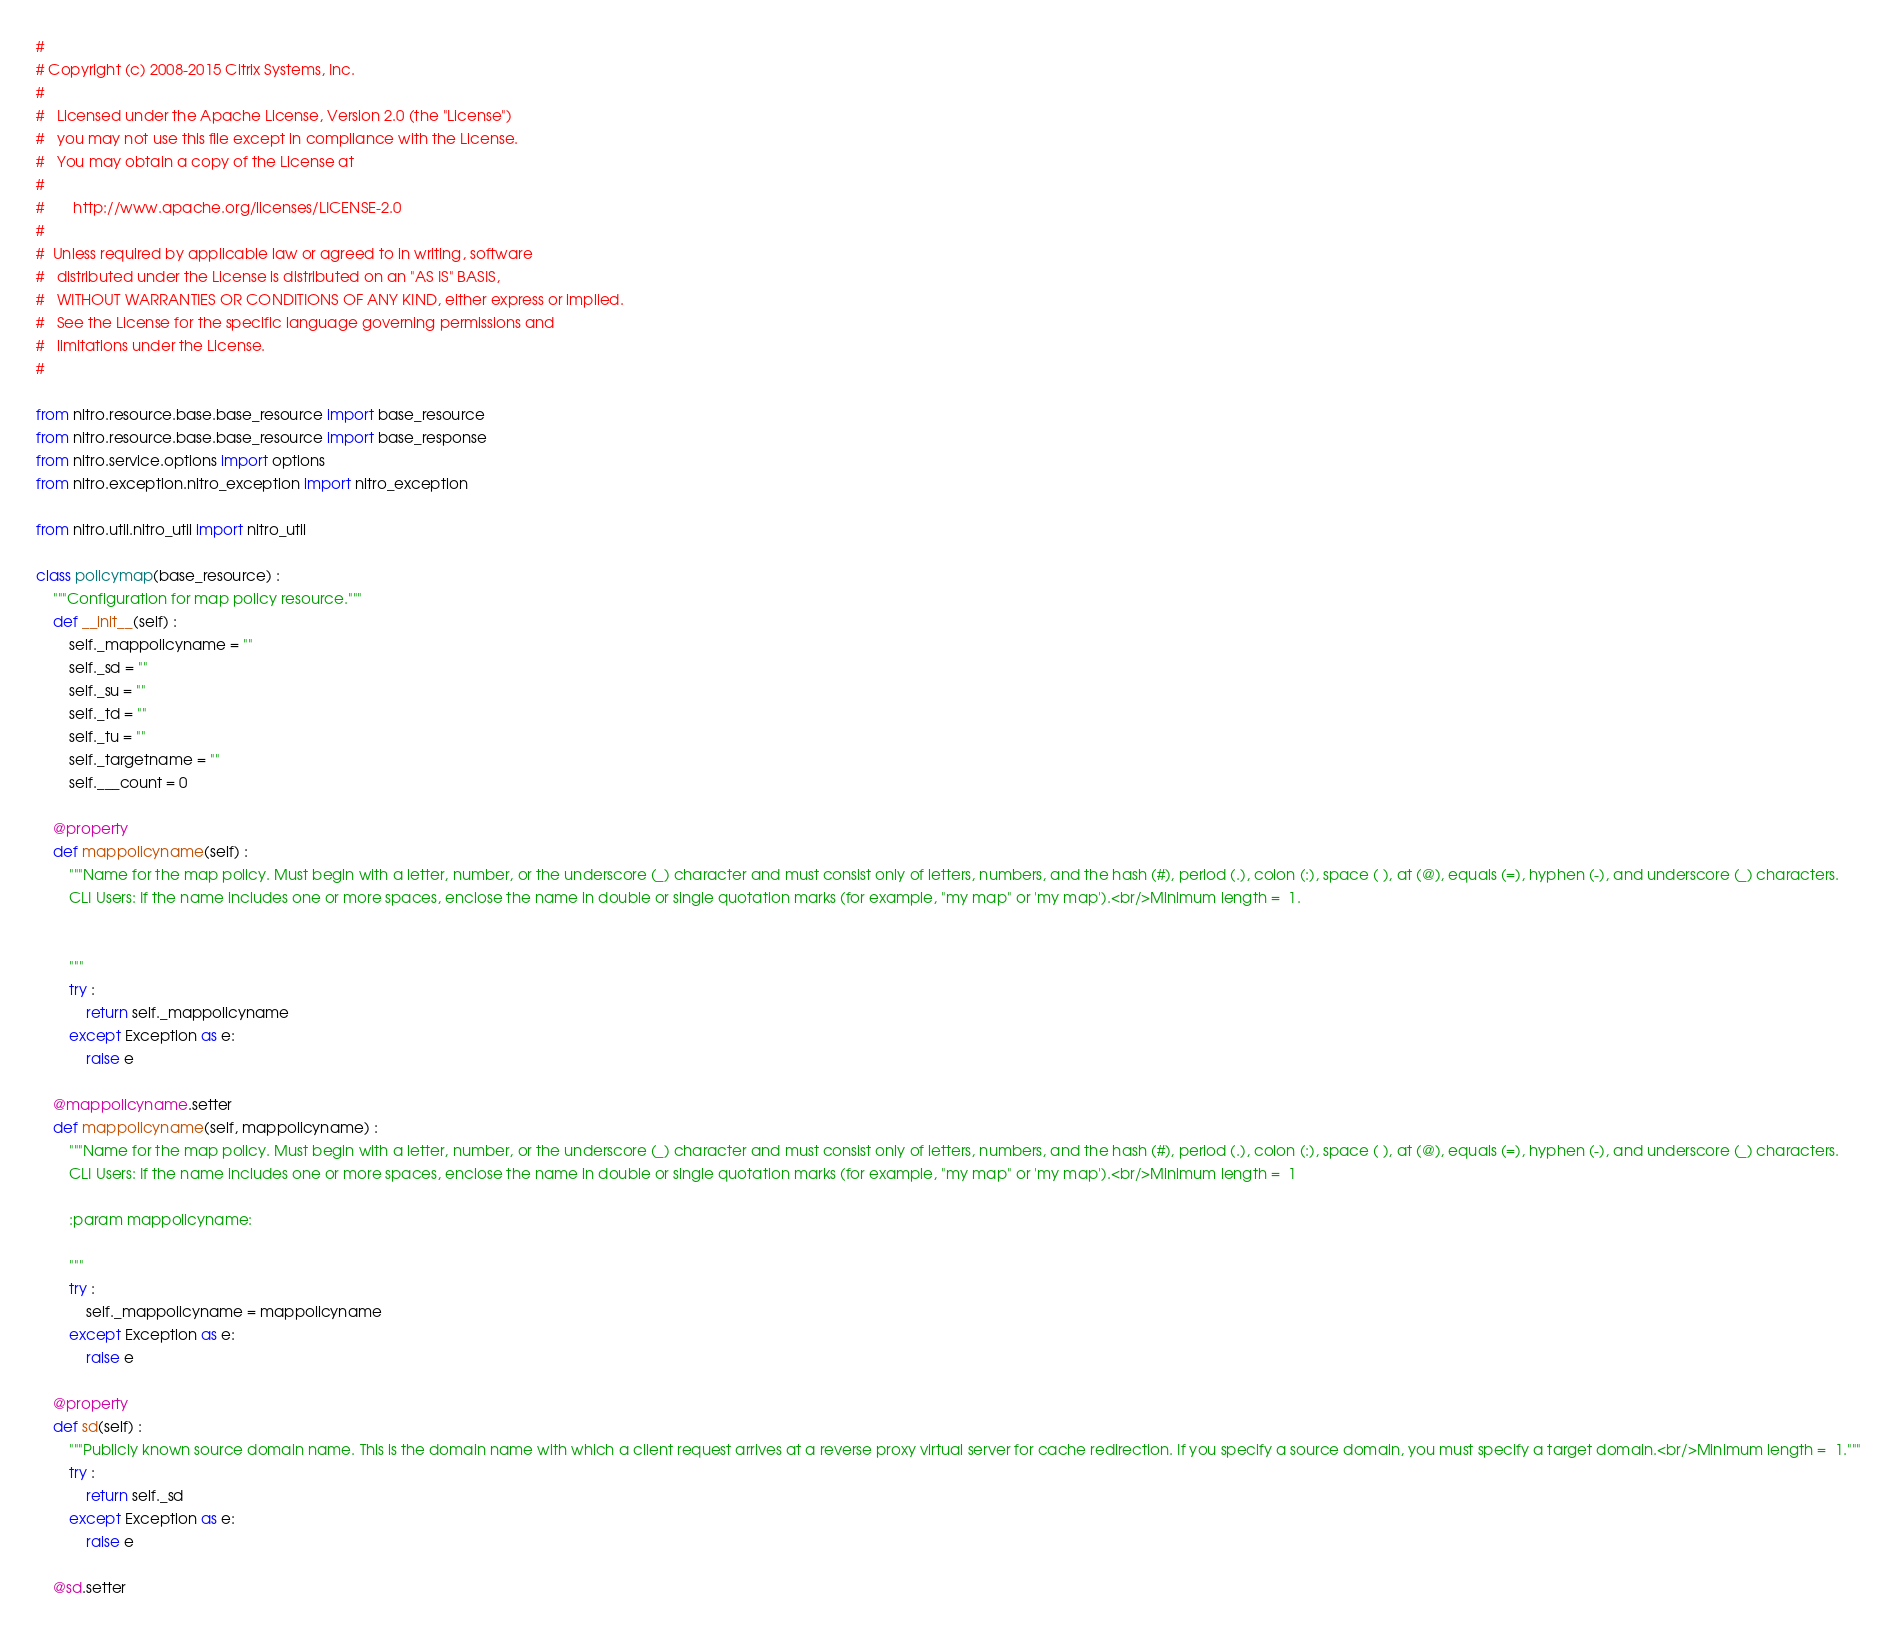Convert code to text. <code><loc_0><loc_0><loc_500><loc_500><_Python_>#
# Copyright (c) 2008-2015 Citrix Systems, Inc.
#
#   Licensed under the Apache License, Version 2.0 (the "License")
#   you may not use this file except in compliance with the License.
#   You may obtain a copy of the License at
#
#       http://www.apache.org/licenses/LICENSE-2.0
#
#  Unless required by applicable law or agreed to in writing, software
#   distributed under the License is distributed on an "AS IS" BASIS,
#   WITHOUT WARRANTIES OR CONDITIONS OF ANY KIND, either express or implied.
#   See the License for the specific language governing permissions and
#   limitations under the License.
#

from nitro.resource.base.base_resource import base_resource
from nitro.resource.base.base_resource import base_response
from nitro.service.options import options
from nitro.exception.nitro_exception import nitro_exception

from nitro.util.nitro_util import nitro_util

class policymap(base_resource) :
    """Configuration for map policy resource."""
    def __init__(self) :
        self._mappolicyname = ""
        self._sd = ""
        self._su = ""
        self._td = ""
        self._tu = ""
        self._targetname = ""
        self.___count = 0

    @property
    def mappolicyname(self) :
        """Name for the map policy. Must begin with a letter, number, or the underscore (_) character and must consist only of letters, numbers, and the hash (#), period (.), colon (:), space ( ), at (@), equals (=), hyphen (-), and underscore (_) characters.
        CLI Users: If the name includes one or more spaces, enclose the name in double or single quotation marks (for example, "my map" or 'my map').<br/>Minimum length =  1.


        """
        try :
            return self._mappolicyname
        except Exception as e:
            raise e

    @mappolicyname.setter
    def mappolicyname(self, mappolicyname) :
        """Name for the map policy. Must begin with a letter, number, or the underscore (_) character and must consist only of letters, numbers, and the hash (#), period (.), colon (:), space ( ), at (@), equals (=), hyphen (-), and underscore (_) characters.
        CLI Users: If the name includes one or more spaces, enclose the name in double or single quotation marks (for example, "my map" or 'my map').<br/>Minimum length =  1

        :param mappolicyname: 

        """
        try :
            self._mappolicyname = mappolicyname
        except Exception as e:
            raise e

    @property
    def sd(self) :
        """Publicly known source domain name. This is the domain name with which a client request arrives at a reverse proxy virtual server for cache redirection. If you specify a source domain, you must specify a target domain.<br/>Minimum length =  1."""
        try :
            return self._sd
        except Exception as e:
            raise e

    @sd.setter</code> 